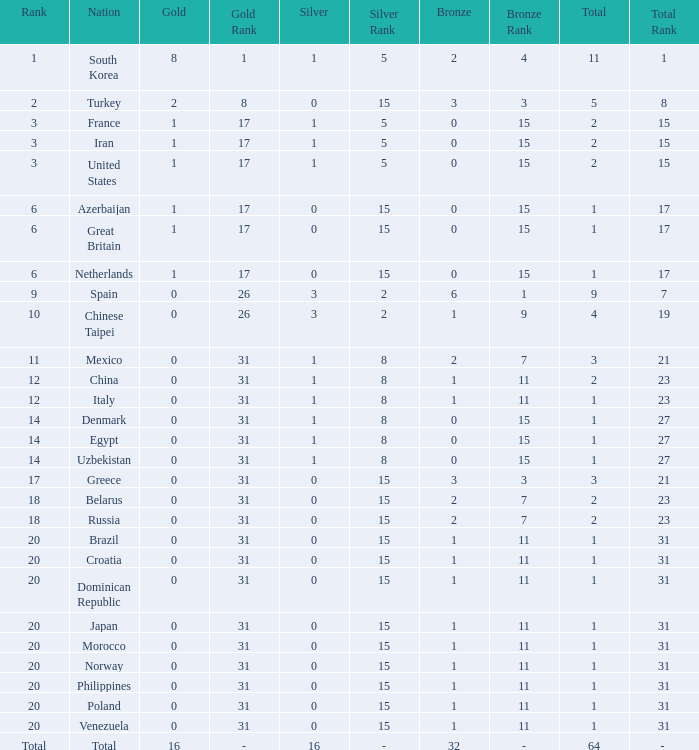Help me parse the entirety of this table. {'header': ['Rank', 'Nation', 'Gold', 'Gold Rank', 'Silver', 'Silver Rank', 'Bronze', 'Bronze Rank', 'Total', 'Total Rank'], 'rows': [['1', 'South Korea', '8', '1', '1', '5', '2', '4', '11', '1'], ['2', 'Turkey', '2', '8', '0', '15', '3', '3', '5', '8'], ['3', 'France', '1', '17', '1', '5', '0', '15', '2', '15'], ['3', 'Iran', '1', '17', '1', '5', '0', '15', '2', '15'], ['3', 'United States', '1', '17', '1', '5', '0', '15', '2', '15'], ['6', 'Azerbaijan', '1', '17', '0', '15', '0', '15', '1', '17'], ['6', 'Great Britain', '1', '17', '0', '15', '0', '15', '1', '17'], ['6', 'Netherlands', '1', '17', '0', '15', '0', '15', '1', '17'], ['9', 'Spain', '0', '26', '3', '2', '6', '1', '9', '7'], ['10', 'Chinese Taipei', '0', '26', '3', '2', '1', '9', '4', '19'], ['11', 'Mexico', '0', '31', '1', '8', '2', '7', '3', '21'], ['12', 'China', '0', '31', '1', '8', '1', '11', '2', '23'], ['12', 'Italy', '0', '31', '1', '8', '1', '11', '1', '23'], ['14', 'Denmark', '0', '31', '1', '8', '0', '15', '1', '27'], ['14', 'Egypt', '0', '31', '1', '8', '0', '15', '1', '27'], ['14', 'Uzbekistan', '0', '31', '1', '8', '0', '15', '1', '27'], ['17', 'Greece', '0', '31', '0', '15', '3', '3', '3', '21'], ['18', 'Belarus', '0', '31', '0', '15', '2', '7', '2', '23'], ['18', 'Russia', '0', '31', '0', '15', '2', '7', '2', '23'], ['20', 'Brazil', '0', '31', '0', '15', '1', '11', '1', '31'], ['20', 'Croatia', '0', '31', '0', '15', '1', '11', '1', '31'], ['20', 'Dominican Republic', '0', '31', '0', '15', '1', '11', '1', '31'], ['20', 'Japan', '0', '31', '0', '15', '1', '11', '1', '31'], ['20', 'Morocco', '0', '31', '0', '15', '1', '11', '1', '31'], ['20', 'Norway', '0', '31', '0', '15', '1', '11', '1', '31'], ['20', 'Philippines', '0', '31', '0', '15', '1', '11', '1', '31'], ['20', 'Poland', '0', '31', '0', '15', '1', '11', '1', '31'], ['20', 'Venezuela', '0', '31', '0', '15', '1', '11', '1', '31'], ['Total', 'Total', '16', '-', '16', '-', '32', '-', '64', '- ']]} What is the average number of bronze of the nation with more than 1 gold and 1 silver medal? 2.0. 